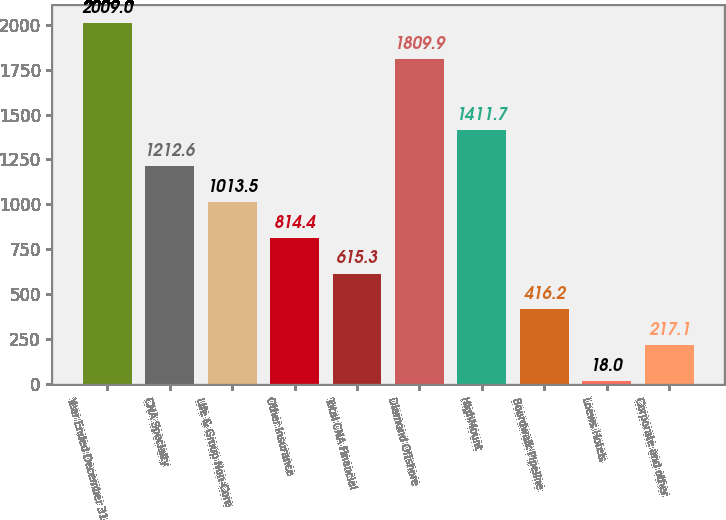<chart> <loc_0><loc_0><loc_500><loc_500><bar_chart><fcel>Year Ended December 31<fcel>CNA Specialty<fcel>Life & Group Non-Core<fcel>Other Insurance<fcel>Total CNA Financial<fcel>Diamond Offshore<fcel>HighMount<fcel>Boardwalk Pipeline<fcel>Loews Hotels<fcel>Corporate and other<nl><fcel>2009<fcel>1212.6<fcel>1013.5<fcel>814.4<fcel>615.3<fcel>1809.9<fcel>1411.7<fcel>416.2<fcel>18<fcel>217.1<nl></chart> 